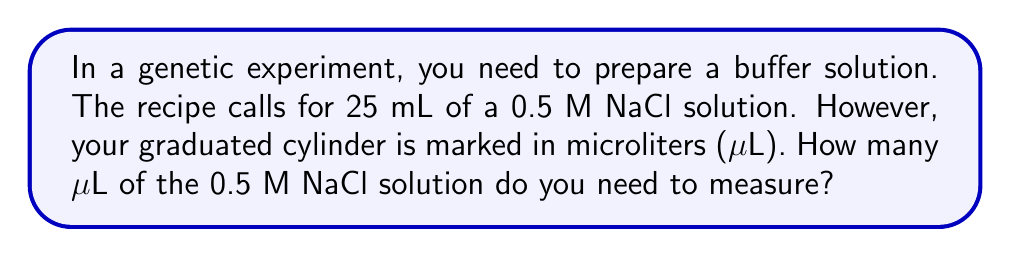Show me your answer to this math problem. To solve this problem, we need to convert milliliters (mL) to microliters (μL). Let's break it down step-by-step:

1. Understand the conversion factor:
   1 mL = 1000 μL

2. Set up the conversion equation:
   $$ 25 \text{ mL} \times \frac{1000 \text{ μL}}{1 \text{ mL}} = x \text{ μL} $$

3. Solve for x:
   $$ x = 25 \times 1000 = 25000 \text{ μL} $$

The conversion is straightforward: we multiply the given volume in mL by 1000 to get the equivalent volume in μL.
Answer: 25000 μL 